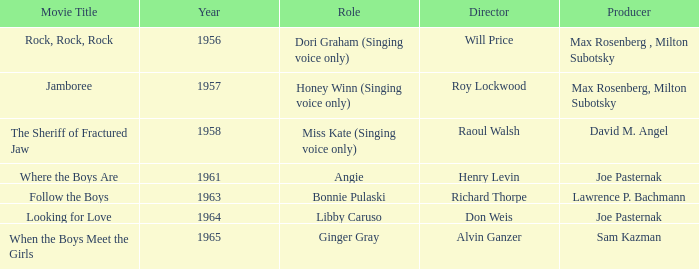What year was Jamboree made? 1957.0. 